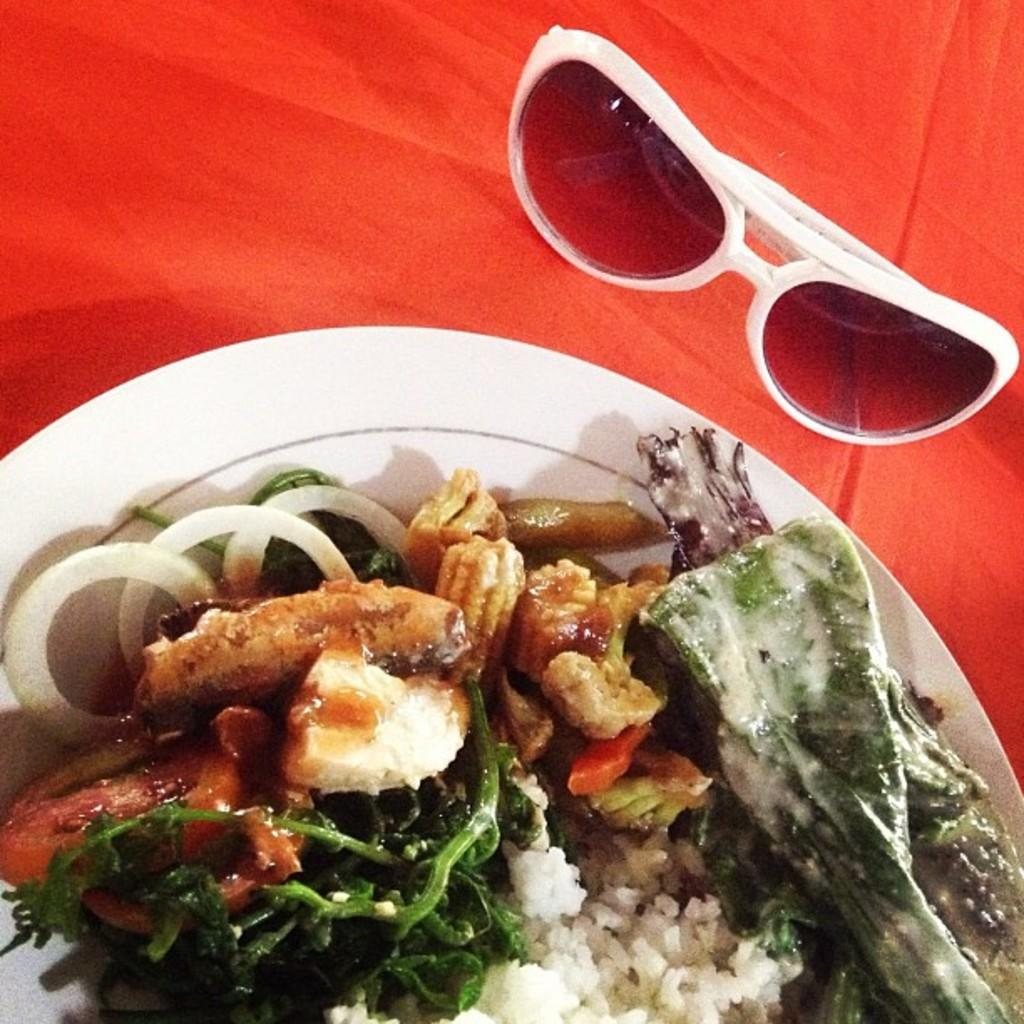What is on the plate that is visible in the image? There is a plate with food items in the image. Can you describe the food items on the plate? The food items include vegetable slices. What other objects can be seen in the image besides the plate with food? There are goggles placed on a red cloth in the image. What type of cake is being served on the sheet in the image? There is no cake or sheet present in the image. 